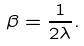<formula> <loc_0><loc_0><loc_500><loc_500>\beta = \frac { 1 } { 2 \lambda } .</formula> 